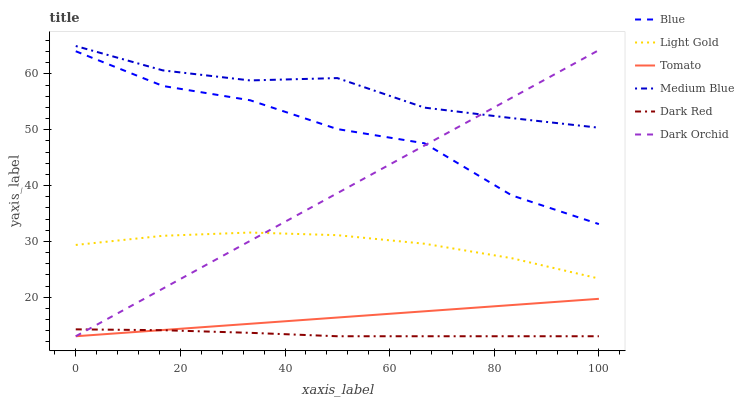Does Dark Red have the minimum area under the curve?
Answer yes or no. Yes. Does Medium Blue have the maximum area under the curve?
Answer yes or no. Yes. Does Tomato have the minimum area under the curve?
Answer yes or no. No. Does Tomato have the maximum area under the curve?
Answer yes or no. No. Is Dark Orchid the smoothest?
Answer yes or no. Yes. Is Blue the roughest?
Answer yes or no. Yes. Is Tomato the smoothest?
Answer yes or no. No. Is Tomato the roughest?
Answer yes or no. No. Does Tomato have the lowest value?
Answer yes or no. Yes. Does Medium Blue have the lowest value?
Answer yes or no. No. Does Medium Blue have the highest value?
Answer yes or no. Yes. Does Tomato have the highest value?
Answer yes or no. No. Is Dark Red less than Blue?
Answer yes or no. Yes. Is Blue greater than Tomato?
Answer yes or no. Yes. Does Light Gold intersect Dark Orchid?
Answer yes or no. Yes. Is Light Gold less than Dark Orchid?
Answer yes or no. No. Is Light Gold greater than Dark Orchid?
Answer yes or no. No. Does Dark Red intersect Blue?
Answer yes or no. No. 